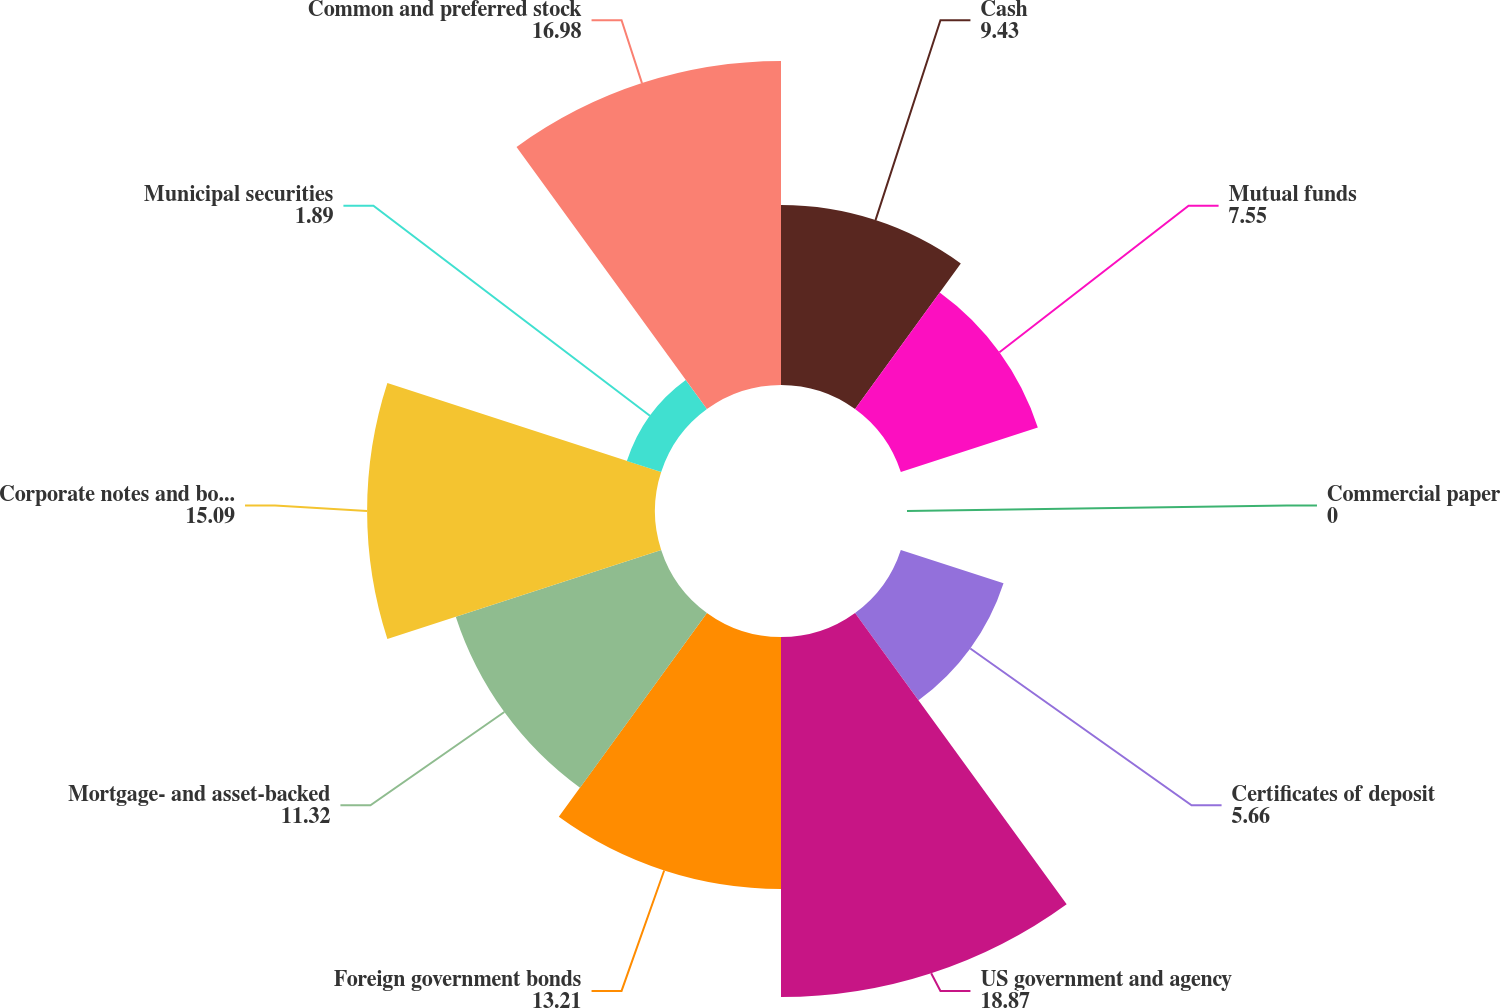Convert chart. <chart><loc_0><loc_0><loc_500><loc_500><pie_chart><fcel>Cash<fcel>Mutual funds<fcel>Commercial paper<fcel>Certificates of deposit<fcel>US government and agency<fcel>Foreign government bonds<fcel>Mortgage- and asset-backed<fcel>Corporate notes and bonds<fcel>Municipal securities<fcel>Common and preferred stock<nl><fcel>9.43%<fcel>7.55%<fcel>0.0%<fcel>5.66%<fcel>18.87%<fcel>13.21%<fcel>11.32%<fcel>15.09%<fcel>1.89%<fcel>16.98%<nl></chart> 